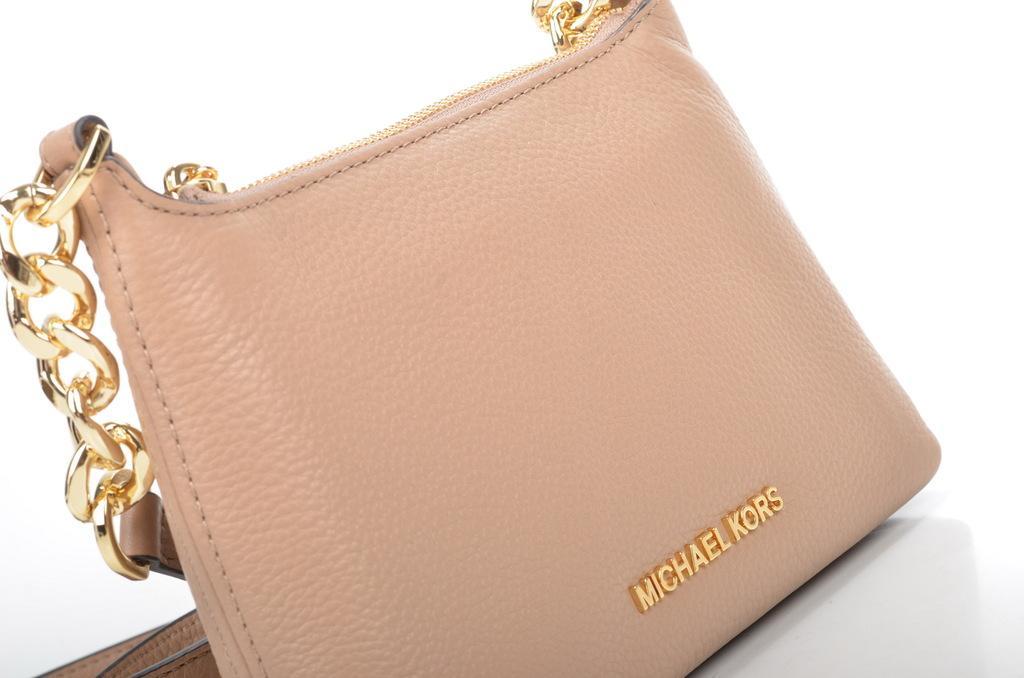How would you summarize this image in a sentence or two? In this image I see handbag, which is of cream in color. 